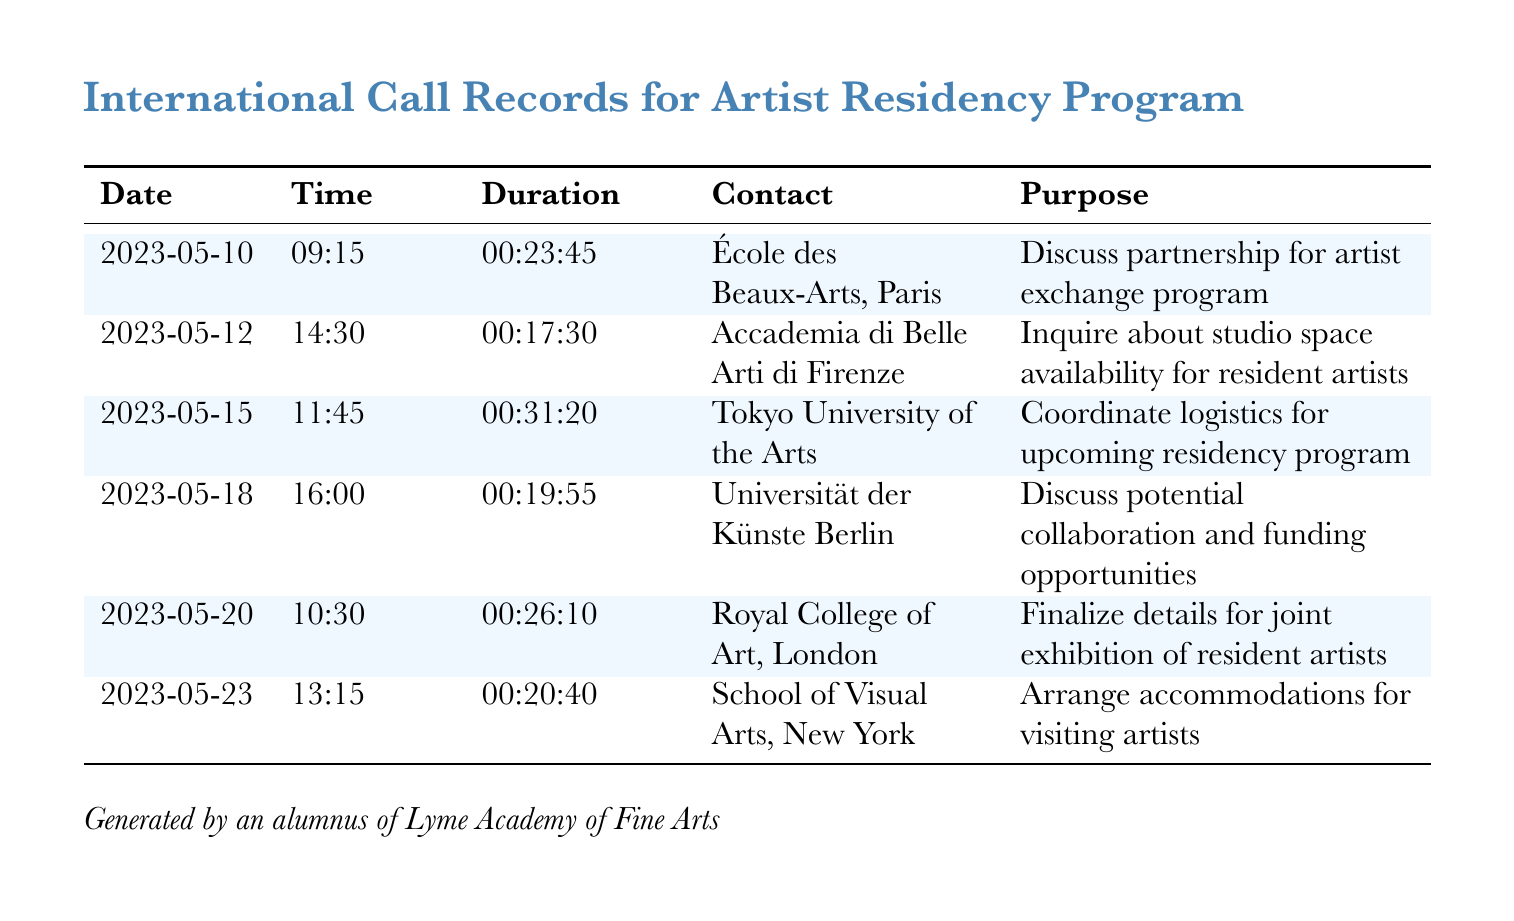What was the duration of the call to École des Beaux-Arts, Paris? The duration is listed in the document under the corresponding date and contact, which is 00:23:45.
Answer: 00:23:45 Which institution was contacted on May 18? This information can be found in the Date and Contact columns, where Universität der Künste Berlin is listed for that date.
Answer: Universität der Künste Berlin How many calls were made in total? The total number of calls can be counted from the rows in the table, which is six calls.
Answer: 6 What was the purpose of the call to Tokyo University of the Arts? The purpose of each call is detailed under the Purpose column, which states that it was to coordinate logistics for the upcoming residency program.
Answer: Coordinate logistics for upcoming residency program Which call had the longest duration? To find this, compare the duration of all calls listed; the longest duration is 00:31:20 for the call to Tokyo University of the Arts.
Answer: 00:31:20 When was the call made to the Royal College of Art, London? The date of this call can be found in the corresponding row, which is May 20.
Answer: 2023-05-20 What was discussed during the call to Accademia di Belle Arti di Firenze? The purpose column indicates that the discussion was about inquiring about studio space availability for resident artists.
Answer: Inquire about studio space availability for resident artists Which call was about arranging accommodations? This pertains to the call made to School of Visual Arts, New York as indicated in the Purpose column.
Answer: School of Visual Arts, New York 